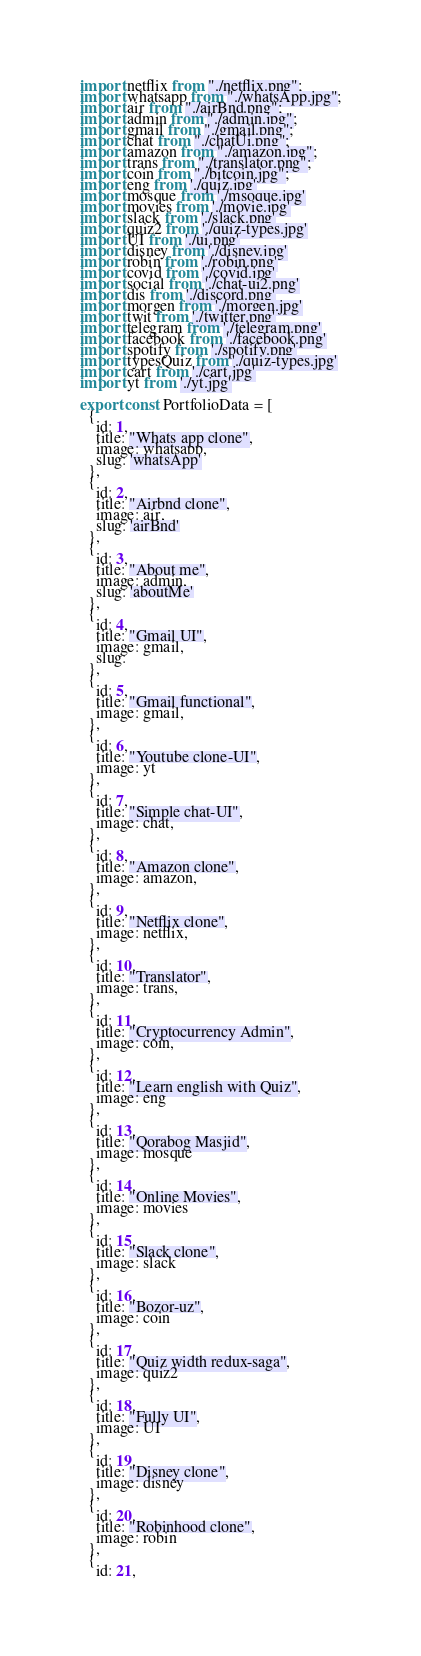<code> <loc_0><loc_0><loc_500><loc_500><_JavaScript_>import netflix from "./netflix.png";
import whatsapp from "./whatsApp.jpg";
import air from "./airBnd.png";
import admin from "./admin.jpg";
import gmail from "./gmail.png";
import chat from "./chatUi.png";
import amazon from "./amazon.jpg";
import trans from "./translator.png";
import coin from "./bitcoin.jpg";
import eng from './quiz.jpg'
import mosque from './msoque.jpg'
import movies from './movie.jpg'
import slack from './slack.png'
import quiz2 from './quiz-types.jpg'
import UI from './ui.png'
import disney from './disney.jpg'
import robin from './robin.png'
import covid from './covid.jpg'
import social from './chat-ui2.png'
import dis from './discord.png'
import morgen from './morgen.jpg'
import twit from './twitter.png'
import telegram from './telegram.png'
import facebook from './facebook.png'
import spotify from './spotify.png'
import typesQuiz from './quiz-types.jpg'
import cart from './cart.jpg'
import yt from './yt.jpg'

export const PortfolioData = [
  {
    id: 1,
    title: "Whats app clone",
    image: whatsapp,
    slug: 'whatsApp'
  },
  {
    id: 2,
    title: "Airbnd clone",
    image: air,
    slug: 'airBnd'
  },
  {
    id: 3,
    title: "About me",
    image: admin,
    slug: 'aboutMe'
  },
  {
    id: 4,
    title: "Gmail UI",
    image: gmail,
    slug: 
  },
  {
    id: 5,
    title: "Gmail functional",
    image: gmail,
  },
  {
    id: 6,
    title: "Youtube clone-UI",
    image: yt
  },
  {
    id: 7,
    title: "Simple chat-UI",
    image: chat,
  },
  {
    id: 8,
    title: "Amazon clone",
    image: amazon,
  },
  {
    id: 9,
    title: "Netflix clone",
    image: netflix,
  },
  {
    id: 10,
    title: "Translator",
    image: trans,
  },
  {
    id: 11,
    title: "Cryptocurrency Admin",
    image: coin,
  },
  {
    id: 12,
    title: "Learn english with Quiz",
    image: eng
  },
  {
    id: 13,
    title: "Qorabog Masjid",
    image: mosque
  },
  {
    id: 14,
    title: "Online Movies",
    image: movies
  },
  {
    id: 15,
    title: "Slack clone",
    image: slack
  },
  {
    id: 16,
    title: "Bozor-uz",
    image: coin
  },
  {
    id: 17,
    title: "Quiz width redux-saga",
    image: quiz2
  },
  {
    id: 18,
    title: "Fully UI",
    image: UI
  },
  {
    id: 19,
    title: "Disney clone",
    image: disney
  },
  {
    id: 20,
    title: "Robinhood clone",
    image: robin
  },
  {
    id: 21,</code> 